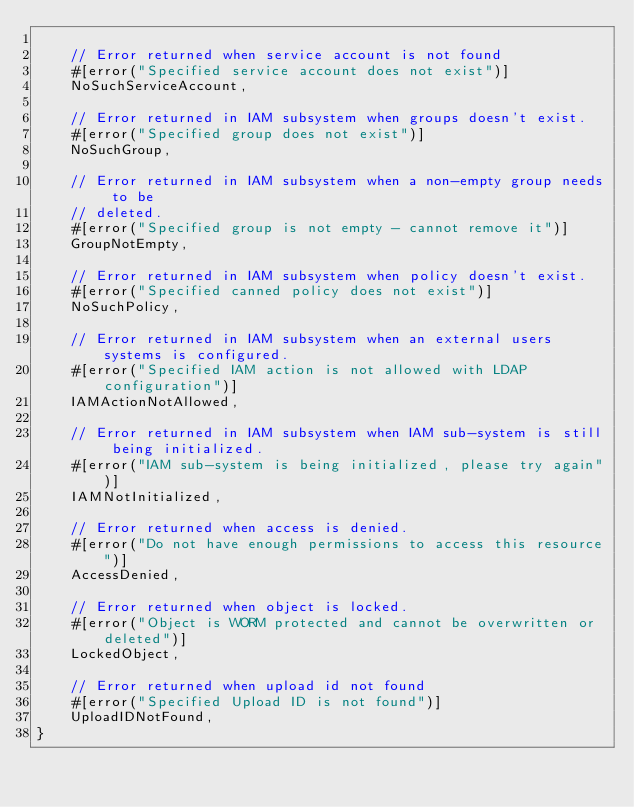Convert code to text. <code><loc_0><loc_0><loc_500><loc_500><_Rust_>
    // Error returned when service account is not found
    #[error("Specified service account does not exist")]
    NoSuchServiceAccount,

    // Error returned in IAM subsystem when groups doesn't exist.
    #[error("Specified group does not exist")]
    NoSuchGroup,

    // Error returned in IAM subsystem when a non-empty group needs to be
    // deleted.
    #[error("Specified group is not empty - cannot remove it")]
    GroupNotEmpty,

    // Error returned in IAM subsystem when policy doesn't exist.
    #[error("Specified canned policy does not exist")]
    NoSuchPolicy,

    // Error returned in IAM subsystem when an external users systems is configured.
    #[error("Specified IAM action is not allowed with LDAP configuration")]
    IAMActionNotAllowed,

    // Error returned in IAM subsystem when IAM sub-system is still being initialized.
    #[error("IAM sub-system is being initialized, please try again")]
    IAMNotInitialized,

    // Error returned when access is denied.
    #[error("Do not have enough permissions to access this resource")]
    AccessDenied,

    // Error returned when object is locked.
    #[error("Object is WORM protected and cannot be overwritten or deleted")]
    LockedObject,

    // Error returned when upload id not found
    #[error("Specified Upload ID is not found")]
    UploadIDNotFound,
}
</code> 